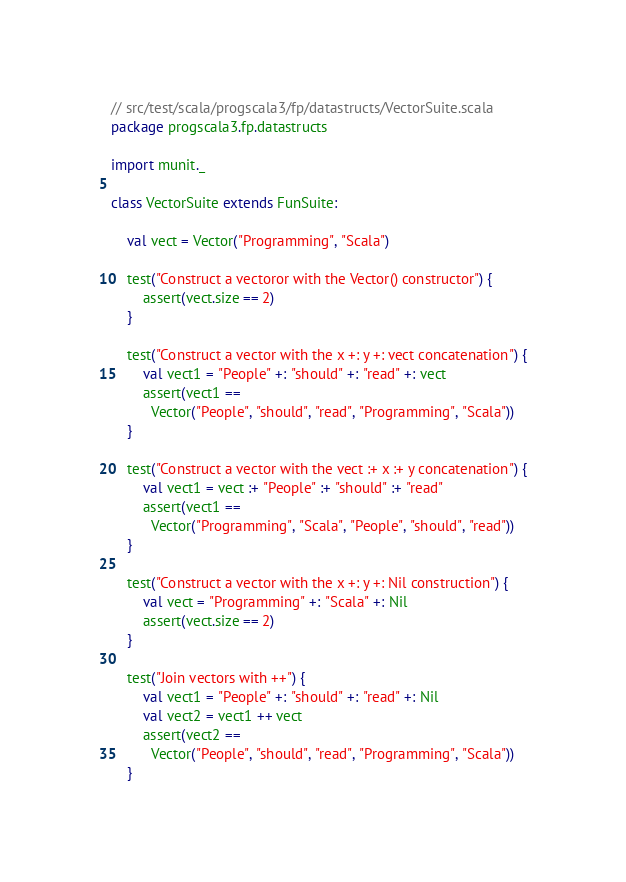Convert code to text. <code><loc_0><loc_0><loc_500><loc_500><_Scala_>// src/test/scala/progscala3/fp/datastructs/VectorSuite.scala
package progscala3.fp.datastructs

import munit._

class VectorSuite extends FunSuite:

	val vect = Vector("Programming", "Scala")

	test("Construct a vectoror with the Vector() constructor") {
		assert(vect.size == 2)
	}

	test("Construct a vector with the x +: y +: vect concatenation") {
		val vect1 = "People" +: "should" +: "read" +: vect
		assert(vect1 ==
		  Vector("People", "should", "read", "Programming", "Scala"))
	}

	test("Construct a vector with the vect :+ x :+ y concatenation") {
		val vect1 = vect :+ "People" :+ "should" :+ "read"
		assert(vect1 ==
		  Vector("Programming", "Scala", "People", "should", "read"))
	}

	test("Construct a vector with the x +: y +: Nil construction") {
		val vect = "Programming" +: "Scala" +: Nil
		assert(vect.size == 2)
	}

	test("Join vectors with ++") {
		val vect1 = "People" +: "should" +: "read" +: Nil
		val vect2 = vect1 ++ vect
		assert(vect2 ==
		  Vector("People", "should", "read", "Programming", "Scala"))
	}
</code> 